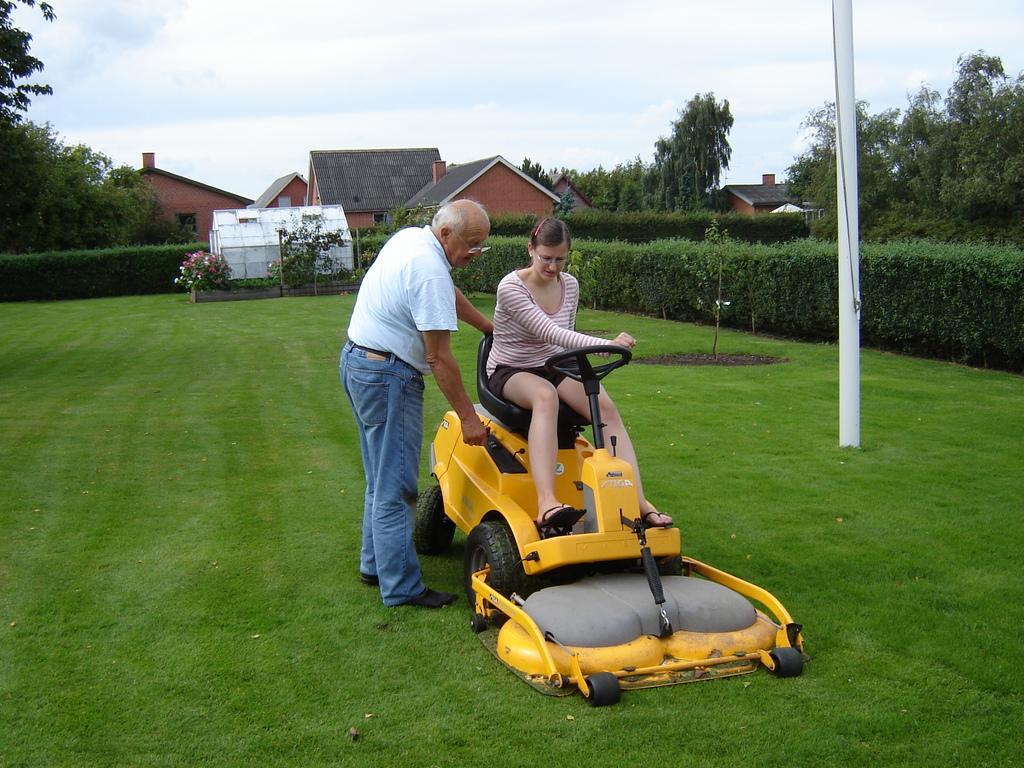Can you describe this image briefly? In this image there is a person sitting on the lawn tractor , another person standing, and in the background there are plants, houses, trees,sky. 